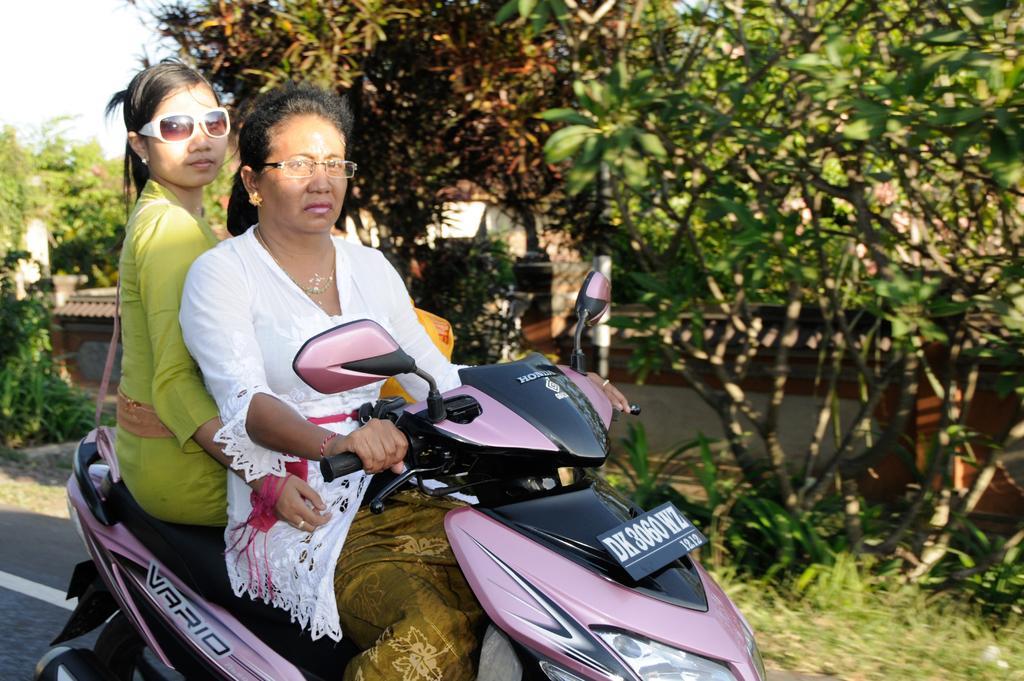In one or two sentences, can you explain what this image depicts? This image is clicked outside. There are trees in this image ,there is a Scooty in the middle, two women are sitting on Scooty. One is wearing white colour dress and other one is wearing green colour dress. Both of them are wearing specs. There is a number plate to that scooty and two Mirrors. 